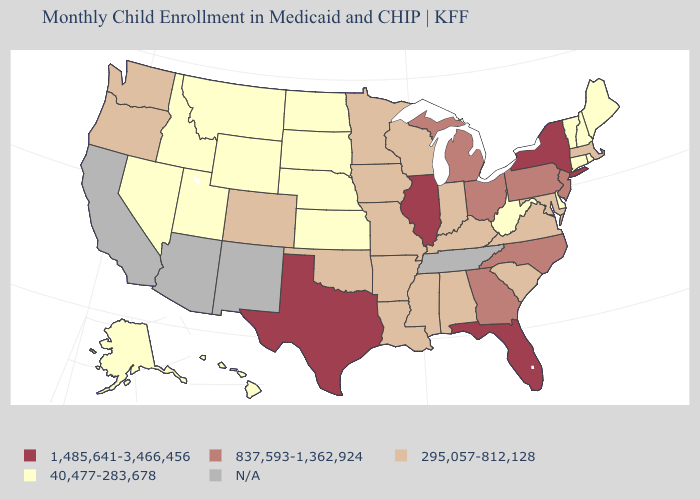Among the states that border Washington , which have the lowest value?
Keep it brief. Idaho. Name the states that have a value in the range N/A?
Concise answer only. Arizona, California, New Mexico, Tennessee. Does Connecticut have the lowest value in the Northeast?
Answer briefly. Yes. Is the legend a continuous bar?
Short answer required. No. Name the states that have a value in the range 837,593-1,362,924?
Short answer required. Georgia, Michigan, New Jersey, North Carolina, Ohio, Pennsylvania. Name the states that have a value in the range 295,057-812,128?
Keep it brief. Alabama, Arkansas, Colorado, Indiana, Iowa, Kentucky, Louisiana, Maryland, Massachusetts, Minnesota, Mississippi, Missouri, Oklahoma, Oregon, South Carolina, Virginia, Washington, Wisconsin. Which states have the lowest value in the USA?
Be succinct. Alaska, Connecticut, Delaware, Hawaii, Idaho, Kansas, Maine, Montana, Nebraska, Nevada, New Hampshire, North Dakota, Rhode Island, South Dakota, Utah, Vermont, West Virginia, Wyoming. Name the states that have a value in the range 295,057-812,128?
Write a very short answer. Alabama, Arkansas, Colorado, Indiana, Iowa, Kentucky, Louisiana, Maryland, Massachusetts, Minnesota, Mississippi, Missouri, Oklahoma, Oregon, South Carolina, Virginia, Washington, Wisconsin. Is the legend a continuous bar?
Write a very short answer. No. Which states have the highest value in the USA?
Be succinct. Florida, Illinois, New York, Texas. Which states have the lowest value in the South?
Answer briefly. Delaware, West Virginia. Name the states that have a value in the range 295,057-812,128?
Short answer required. Alabama, Arkansas, Colorado, Indiana, Iowa, Kentucky, Louisiana, Maryland, Massachusetts, Minnesota, Mississippi, Missouri, Oklahoma, Oregon, South Carolina, Virginia, Washington, Wisconsin. Which states have the lowest value in the USA?
Short answer required. Alaska, Connecticut, Delaware, Hawaii, Idaho, Kansas, Maine, Montana, Nebraska, Nevada, New Hampshire, North Dakota, Rhode Island, South Dakota, Utah, Vermont, West Virginia, Wyoming. Name the states that have a value in the range 295,057-812,128?
Concise answer only. Alabama, Arkansas, Colorado, Indiana, Iowa, Kentucky, Louisiana, Maryland, Massachusetts, Minnesota, Mississippi, Missouri, Oklahoma, Oregon, South Carolina, Virginia, Washington, Wisconsin. 